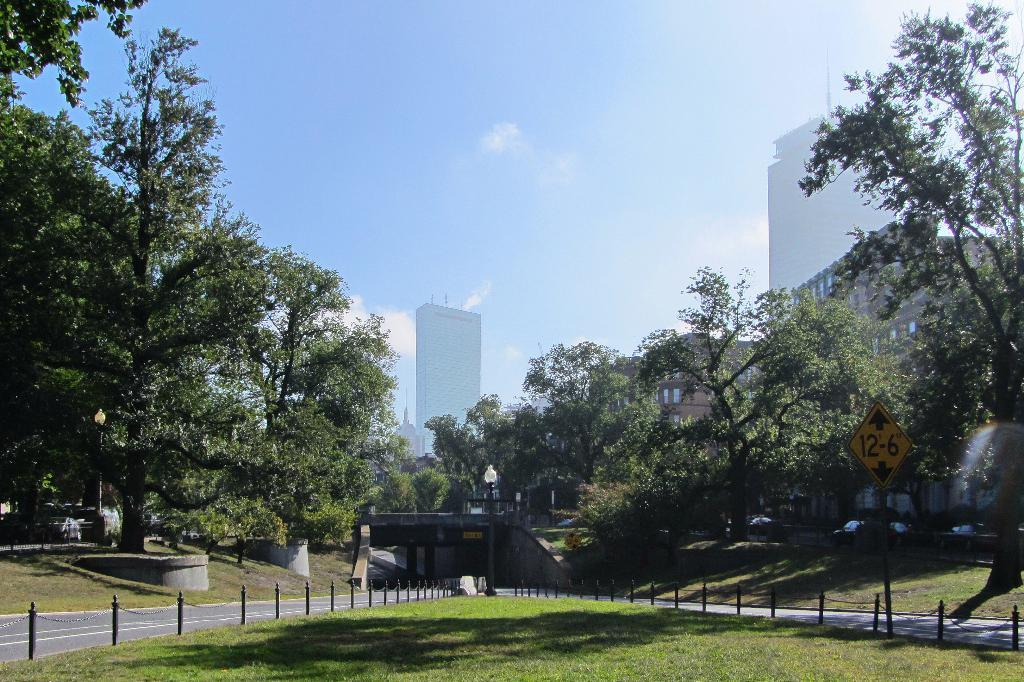What type of surface is visible in the image? There is a grassy surface in the image. What else can be seen on the ground in the image? There is a road in the image. What can be seen in the background of the image? Trees, a part of a building, and the sky are visible in the background of the image. What is the condition of the sky in the image? Clouds are present in the sky. What type of flame can be seen coming from the trees in the image? There is no flame present in the image; it features a grassy surface, a road, trees, a part of a building, and the sky with clouds. 